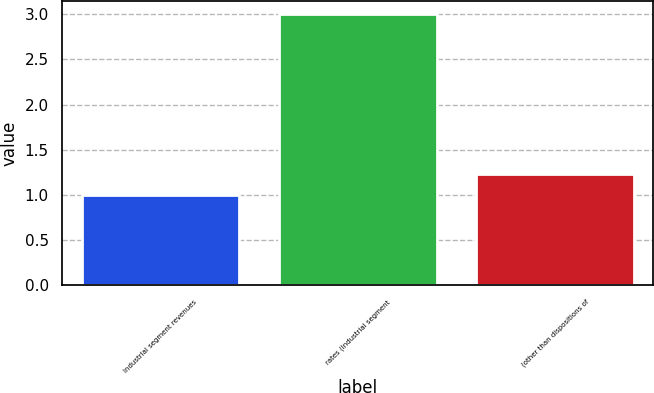<chart> <loc_0><loc_0><loc_500><loc_500><bar_chart><fcel>Industrial segment revenues<fcel>rates (Industrial segment<fcel>(other than dispositions of<nl><fcel>1<fcel>3<fcel>1.23<nl></chart> 